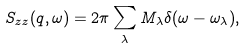<formula> <loc_0><loc_0><loc_500><loc_500>S _ { z z } ( q , \omega ) = 2 \pi \sum _ { \lambda } M _ { \lambda } \delta ( \omega - \omega _ { \lambda } ) ,</formula> 